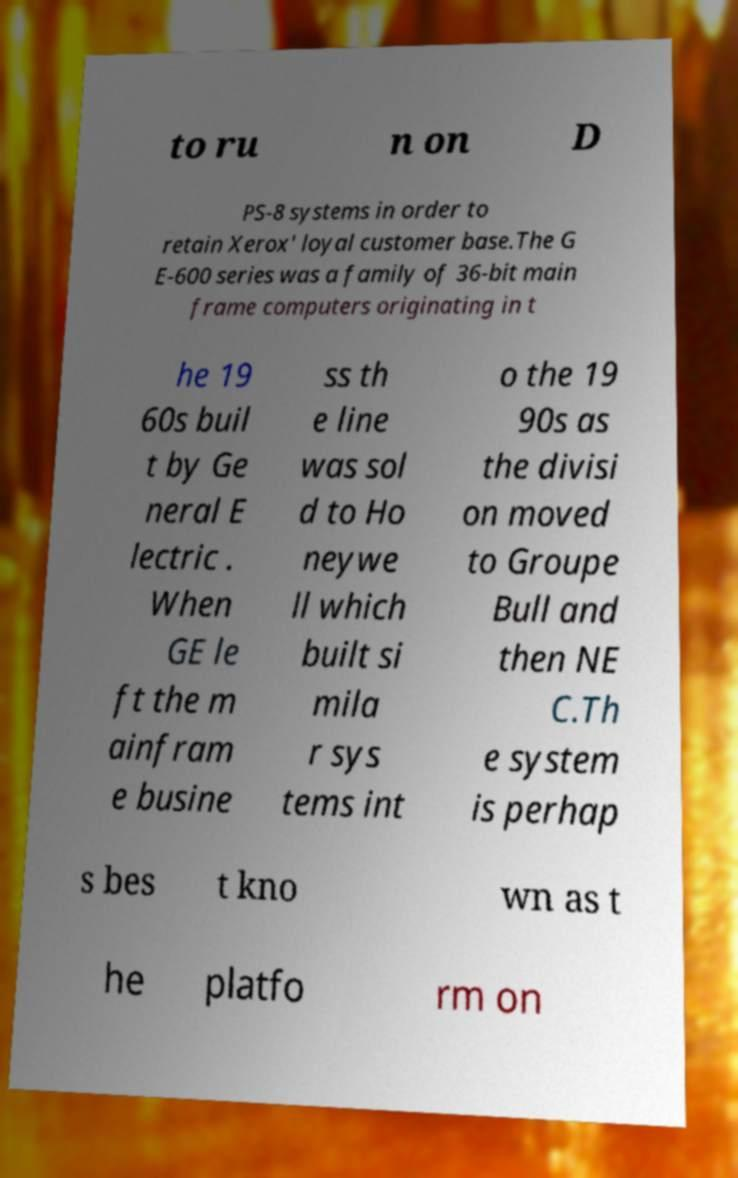Could you extract and type out the text from this image? to ru n on D PS-8 systems in order to retain Xerox' loyal customer base.The G E-600 series was a family of 36-bit main frame computers originating in t he 19 60s buil t by Ge neral E lectric . When GE le ft the m ainfram e busine ss th e line was sol d to Ho neywe ll which built si mila r sys tems int o the 19 90s as the divisi on moved to Groupe Bull and then NE C.Th e system is perhap s bes t kno wn as t he platfo rm on 